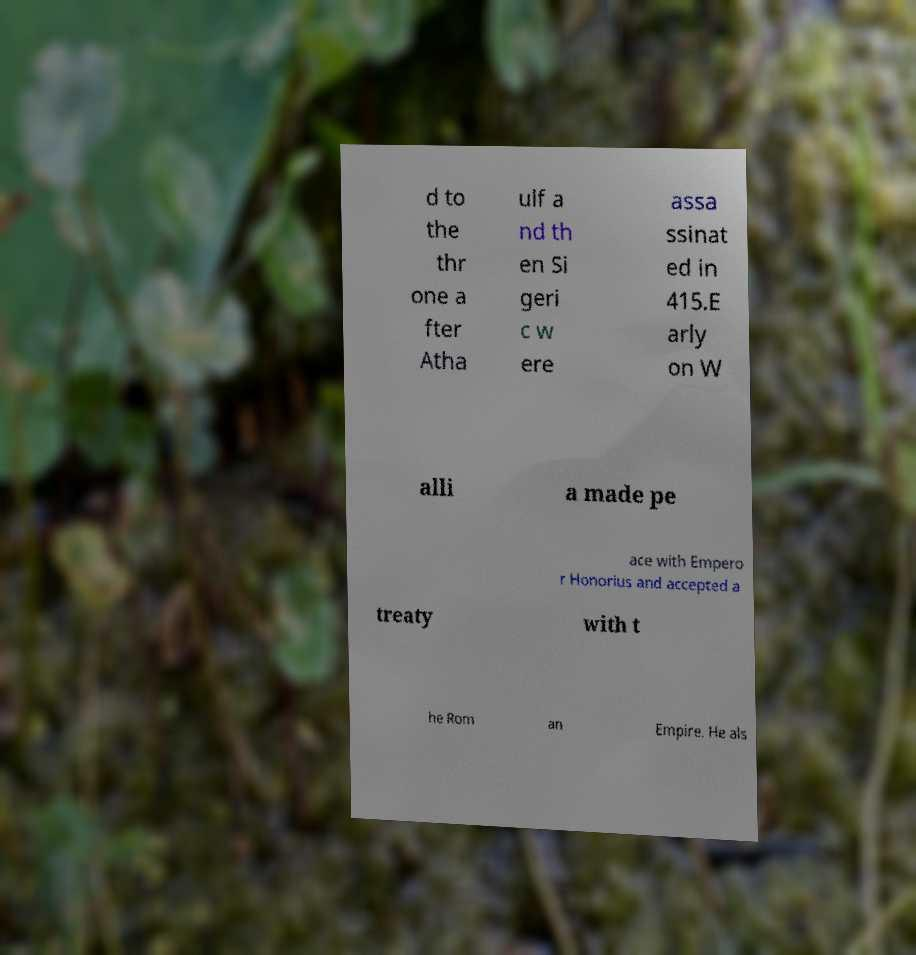Can you read and provide the text displayed in the image?This photo seems to have some interesting text. Can you extract and type it out for me? d to the thr one a fter Atha ulf a nd th en Si geri c w ere assa ssinat ed in 415.E arly on W alli a made pe ace with Empero r Honorius and accepted a treaty with t he Rom an Empire. He als 